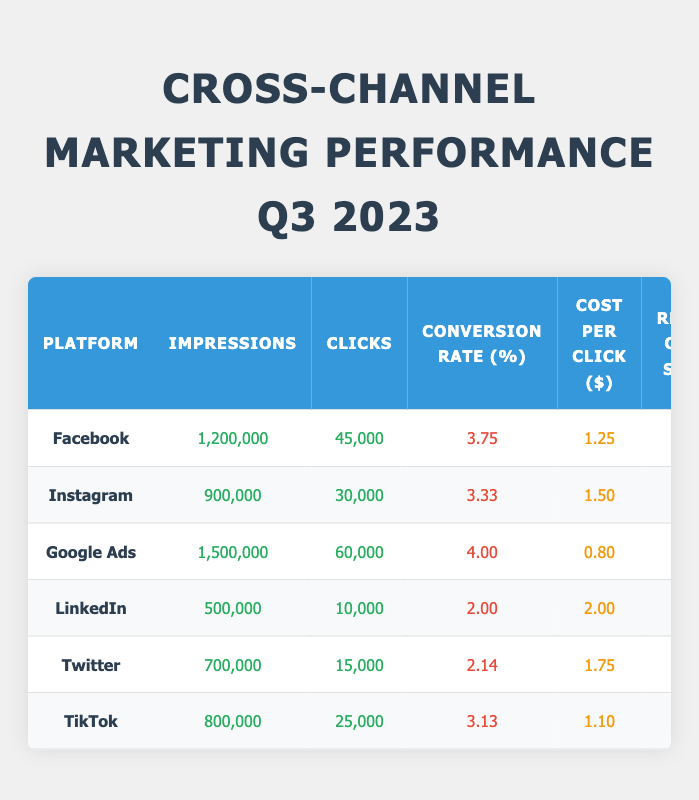What is the platform with the highest number of impressions? Looking at the "Impressions" column, Google Ads has the highest value at 1,500,000.
Answer: Google Ads What is the conversion rate for Facebook? The conversion rate for Facebook, as shown in the "Conversion Rate (%)" column, is 3.75%.
Answer: 3.75% Which platform has the lowest cost per click? The "Cost per Click ($)" column shows that Google Ads has the lowest cost, at $0.80 per click.
Answer: Google Ads What is the total number of clicks across all platforms? To find the total number of clicks, sum the values from the "Clicks" column: 45,000 + 30,000 + 60,000 + 10,000 + 15,000 + 25,000 = 185,000.
Answer: 185,000 Which platform has the highest return on ad spend? By examining the "Return on Ad Spend" column, Google Ads has the highest value at 6.0.
Answer: Google Ads Is Facebook’s conversion rate higher than Twitter’s? Facebook has a conversion rate of 3.75%, while Twitter’s is 2.14%. Since 3.75% > 2.14%, the statement is true.
Answer: Yes What is the average cost per click among all platforms? To find the average cost per click, sum the values from the "Cost per Click ($)" column (1.25 + 1.50 + 0.80 + 2.00 + 1.75 + 1.10 = 8.40) and divide by the number of platforms (6): 8.40 / 6 = 1.40.
Answer: 1.40 How many more clicks does Google Ads have compared to LinkedIn? Google Ads has 60,000 clicks, while LinkedIn has 10,000. The difference is calculated as 60,000 - 10,000 = 50,000.
Answer: 50,000 Is TikTok's conversion rate greater than Instagram's? TikTok has a conversion rate of 3.13%, while Instagram has 3.33%. Since 3.13% < 3.33%, the statement is false.
Answer: No What is the total number of impressions for Facebook and Instagram combined? To find the total impressions for Facebook and Instagram, sum their "Impressions" values: 1,200,000 (Facebook) + 900,000 (Instagram) = 2,100,000.
Answer: 2,100,000 